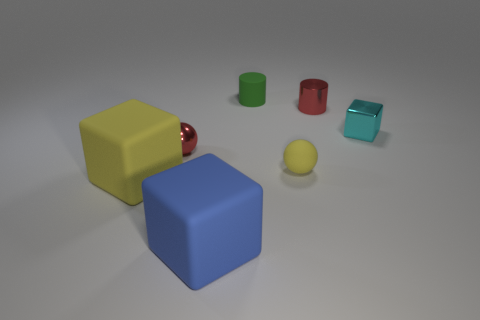What is the size of the rubber block that is the same color as the small rubber ball?
Your response must be concise. Large. There is a cylinder that is to the left of the small yellow ball; what is it made of?
Make the answer very short. Rubber. What number of large matte blocks are the same color as the metallic sphere?
Your answer should be very brief. 0. There is a tiny thing that is the same color as the small shiny cylinder; what material is it?
Ensure brevity in your answer.  Metal. There is a yellow matte thing that is the same shape as the blue matte thing; what size is it?
Keep it short and to the point. Large. What size is the cube that is both behind the big blue rubber thing and in front of the tiny yellow ball?
Give a very brief answer. Large. Is the material of the tiny ball that is left of the large blue block the same as the green object?
Offer a very short reply. No. The small thing that is in front of the small metallic object in front of the small cyan thing behind the large yellow block is made of what material?
Your answer should be very brief. Rubber. What number of metallic objects are either large cyan things or tiny things?
Provide a short and direct response. 3. Is there a yellow metal object?
Provide a succinct answer. No. 